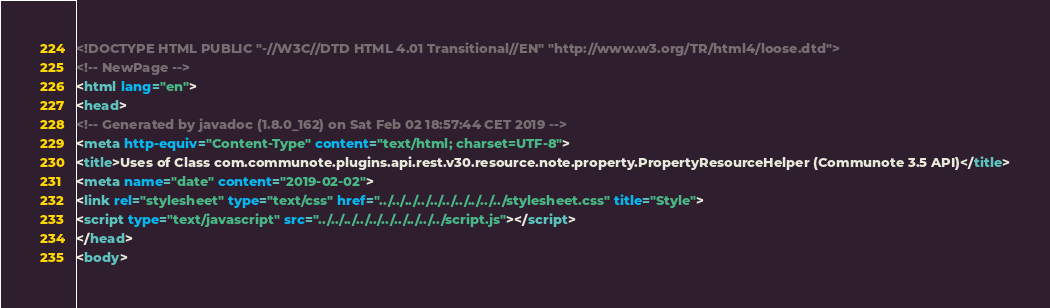<code> <loc_0><loc_0><loc_500><loc_500><_HTML_><!DOCTYPE HTML PUBLIC "-//W3C//DTD HTML 4.01 Transitional//EN" "http://www.w3.org/TR/html4/loose.dtd">
<!-- NewPage -->
<html lang="en">
<head>
<!-- Generated by javadoc (1.8.0_162) on Sat Feb 02 18:57:44 CET 2019 -->
<meta http-equiv="Content-Type" content="text/html; charset=UTF-8">
<title>Uses of Class com.communote.plugins.api.rest.v30.resource.note.property.PropertyResourceHelper (Communote 3.5 API)</title>
<meta name="date" content="2019-02-02">
<link rel="stylesheet" type="text/css" href="../../../../../../../../../../stylesheet.css" title="Style">
<script type="text/javascript" src="../../../../../../../../../../script.js"></script>
</head>
<body></code> 